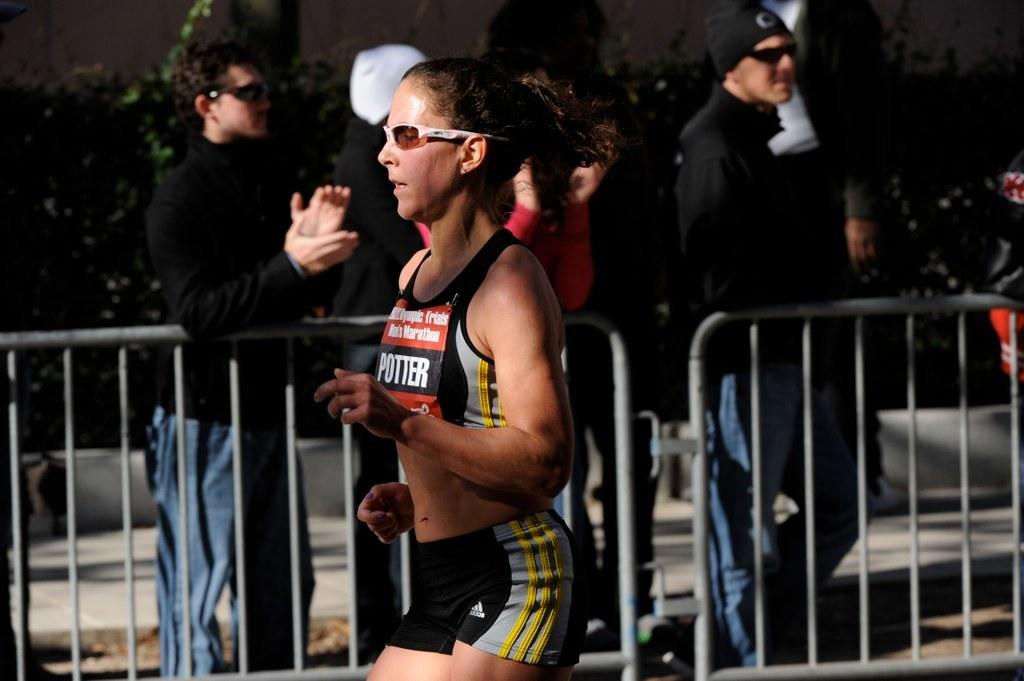<image>
Share a concise interpretation of the image provided. A runner with the name Potter is competing during an athletics event. 